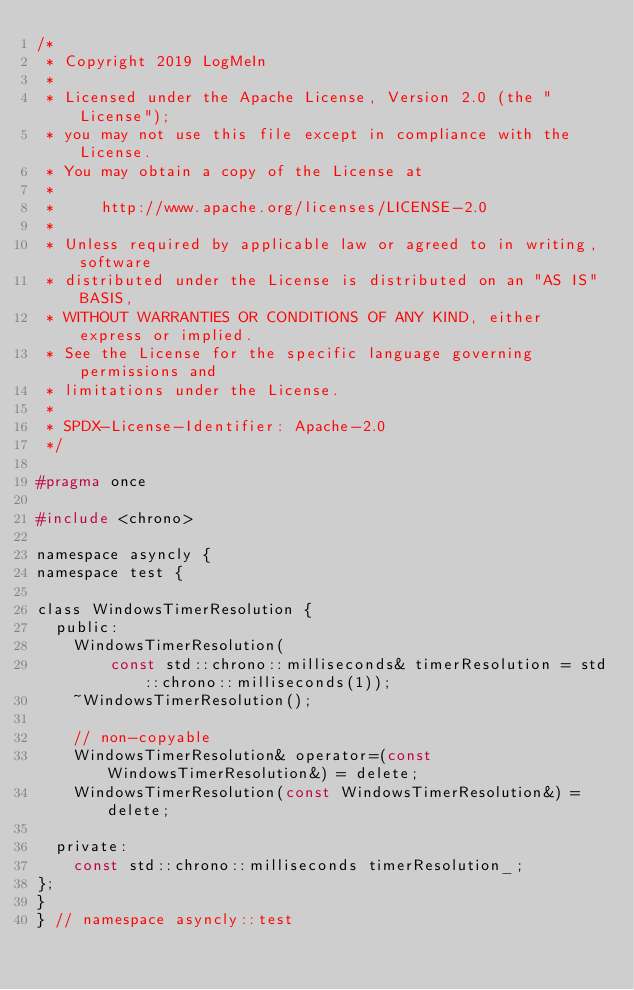Convert code to text. <code><loc_0><loc_0><loc_500><loc_500><_C_>/*
 * Copyright 2019 LogMeIn
 *
 * Licensed under the Apache License, Version 2.0 (the "License");
 * you may not use this file except in compliance with the License.
 * You may obtain a copy of the License at
 *
 *     http://www.apache.org/licenses/LICENSE-2.0
 *
 * Unless required by applicable law or agreed to in writing, software
 * distributed under the License is distributed on an "AS IS" BASIS,
 * WITHOUT WARRANTIES OR CONDITIONS OF ANY KIND, either express or implied.
 * See the License for the specific language governing permissions and
 * limitations under the License.
 *
 * SPDX-License-Identifier: Apache-2.0
 */

#pragma once

#include <chrono>

namespace asyncly {
namespace test {

class WindowsTimerResolution {
  public:
    WindowsTimerResolution(
        const std::chrono::milliseconds& timerResolution = std::chrono::milliseconds(1));
    ~WindowsTimerResolution();

    // non-copyable
    WindowsTimerResolution& operator=(const WindowsTimerResolution&) = delete;
    WindowsTimerResolution(const WindowsTimerResolution&) = delete;

  private:
    const std::chrono::milliseconds timerResolution_;
};
}
} // namespace asyncly::test
</code> 